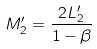Convert formula to latex. <formula><loc_0><loc_0><loc_500><loc_500>M _ { 2 } ^ { \prime } = \frac { 2 L _ { 2 } ^ { \prime } } { 1 - \beta }</formula> 